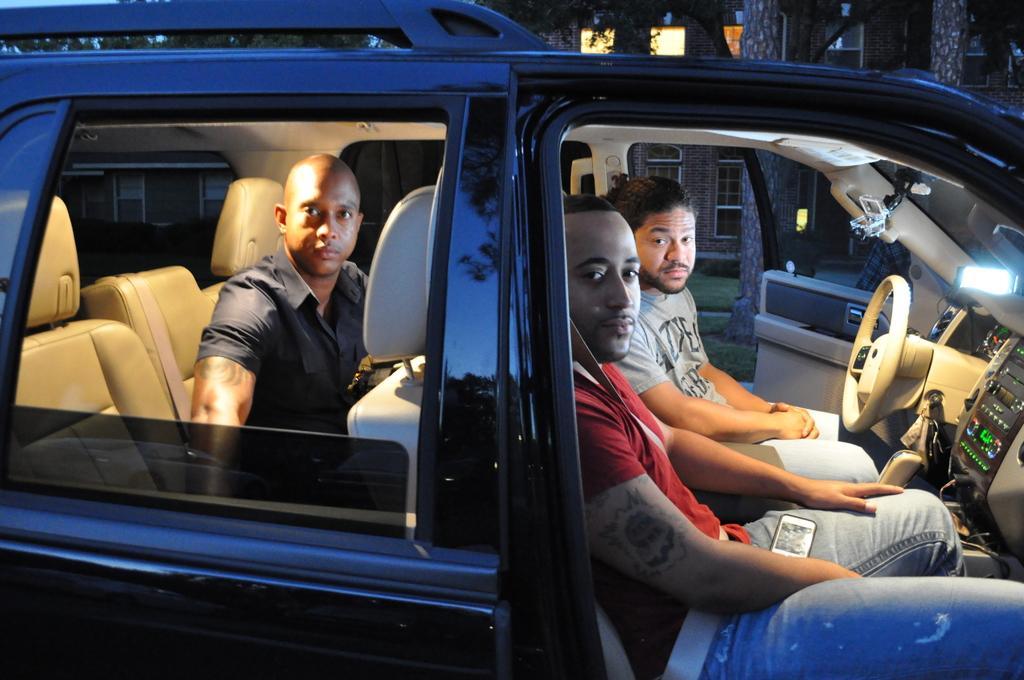Could you give a brief overview of what you see in this image? In this image there are three persons sitting in a car. The car is in blue color. The man sitting in back seat is wearing a black shirt. The sitting in front of the steering is wearing a gray t-shirt. The man in the front is wearing a red t-shirt. And in the background there are many trees and a building. 